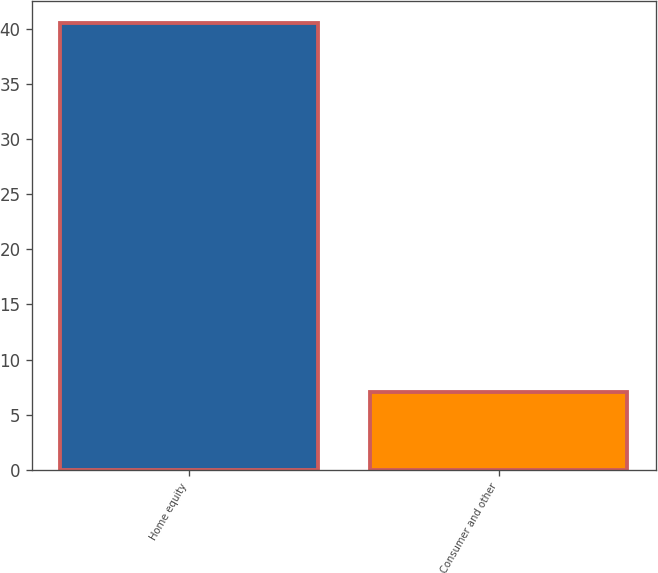Convert chart to OTSL. <chart><loc_0><loc_0><loc_500><loc_500><bar_chart><fcel>Home equity<fcel>Consumer and other<nl><fcel>40.5<fcel>7.1<nl></chart> 